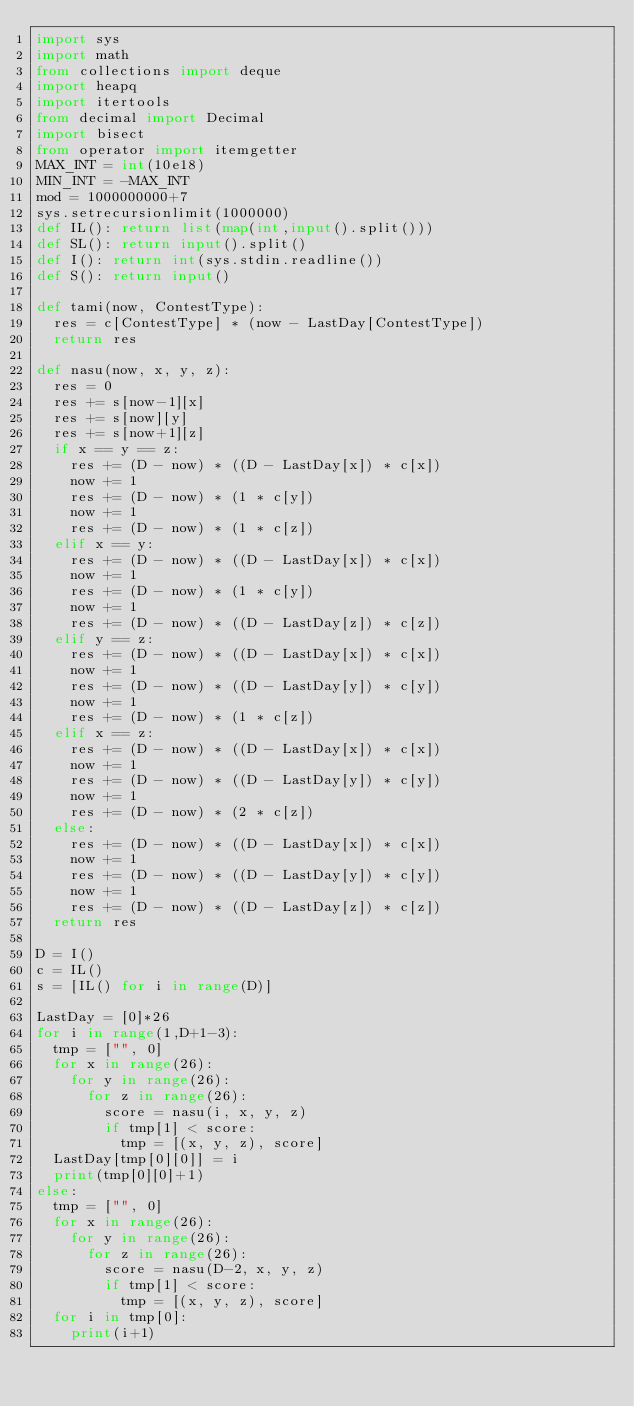Convert code to text. <code><loc_0><loc_0><loc_500><loc_500><_Python_>import sys
import math
from collections import deque
import heapq
import itertools
from decimal import Decimal
import bisect
from operator import itemgetter
MAX_INT = int(10e18)
MIN_INT = -MAX_INT
mod = 1000000000+7
sys.setrecursionlimit(1000000)
def IL(): return list(map(int,input().split()))
def SL(): return input().split()
def I(): return int(sys.stdin.readline())
def S(): return input()

def tami(now, ContestType):
  res = c[ContestType] * (now - LastDay[ContestType])
  return res

def nasu(now, x, y, z):
  res = 0
  res += s[now-1][x]
  res += s[now][y]
  res += s[now+1][z]
  if x == y == z:
    res += (D - now) * ((D - LastDay[x]) * c[x])
    now += 1
    res += (D - now) * (1 * c[y])
    now += 1
    res += (D - now) * (1 * c[z])
  elif x == y:
    res += (D - now) * ((D - LastDay[x]) * c[x])
    now += 1
    res += (D - now) * (1 * c[y])
    now += 1
    res += (D - now) * ((D - LastDay[z]) * c[z])
  elif y == z:
    res += (D - now) * ((D - LastDay[x]) * c[x])
    now += 1
    res += (D - now) * ((D - LastDay[y]) * c[y])
    now += 1
    res += (D - now) * (1 * c[z])
  elif x == z:
    res += (D - now) * ((D - LastDay[x]) * c[x])
    now += 1
    res += (D - now) * ((D - LastDay[y]) * c[y])
    now += 1
    res += (D - now) * (2 * c[z])
  else:
    res += (D - now) * ((D - LastDay[x]) * c[x])
    now += 1
    res += (D - now) * ((D - LastDay[y]) * c[y])
    now += 1
    res += (D - now) * ((D - LastDay[z]) * c[z])
  return res

D = I()
c = IL()
s = [IL() for i in range(D)]

LastDay = [0]*26
for i in range(1,D+1-3):
  tmp = ["", 0]
  for x in range(26):
    for y in range(26):
      for z in range(26):
        score = nasu(i, x, y, z)
        if tmp[1] < score:
          tmp = [(x, y, z), score]
  LastDay[tmp[0][0]] = i
  print(tmp[0][0]+1)
else:
  tmp = ["", 0]
  for x in range(26):
    for y in range(26):
      for z in range(26):
        score = nasu(D-2, x, y, z)
        if tmp[1] < score:
          tmp = [(x, y, z), score]
  for i in tmp[0]:
    print(i+1)</code> 